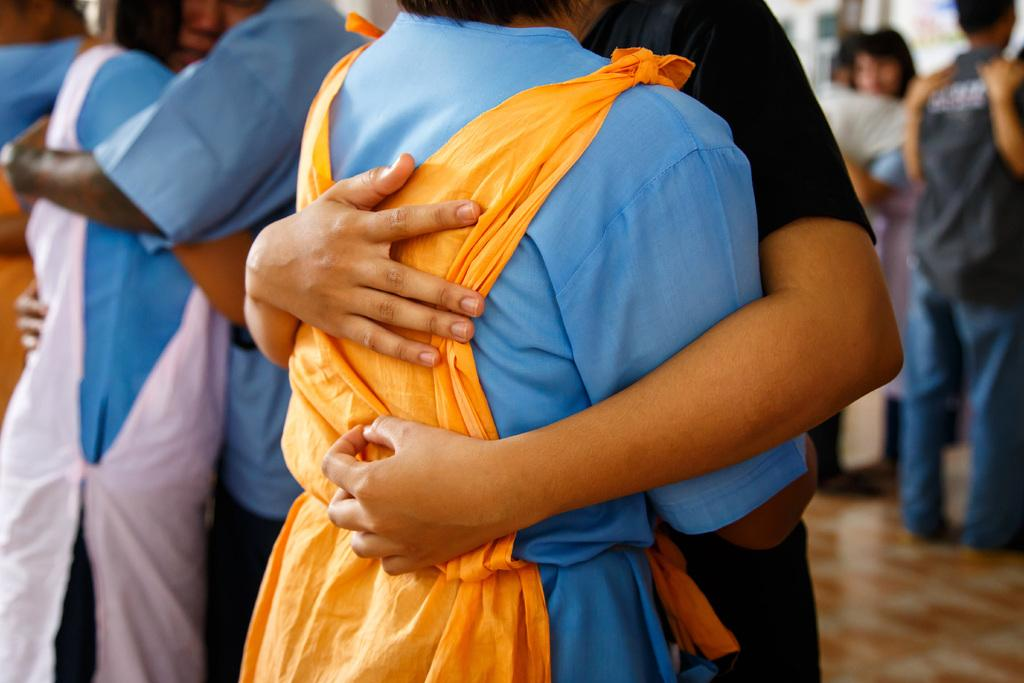Who or what is present in the image? There are people in the image. What are the people doing in the image? The people are hugging each other. What surface can be seen beneath the people in the image? There is a floor visible in the image. What color is the balloon in the image? There is no balloon present in the image. 